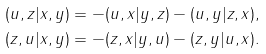<formula> <loc_0><loc_0><loc_500><loc_500>( u , z | x , y ) = - ( u , x | y , z ) - ( u , y | z , x ) , \\ ( z , u | x , y ) = - ( z , x | y , u ) - ( z , y | u , x ) .</formula> 